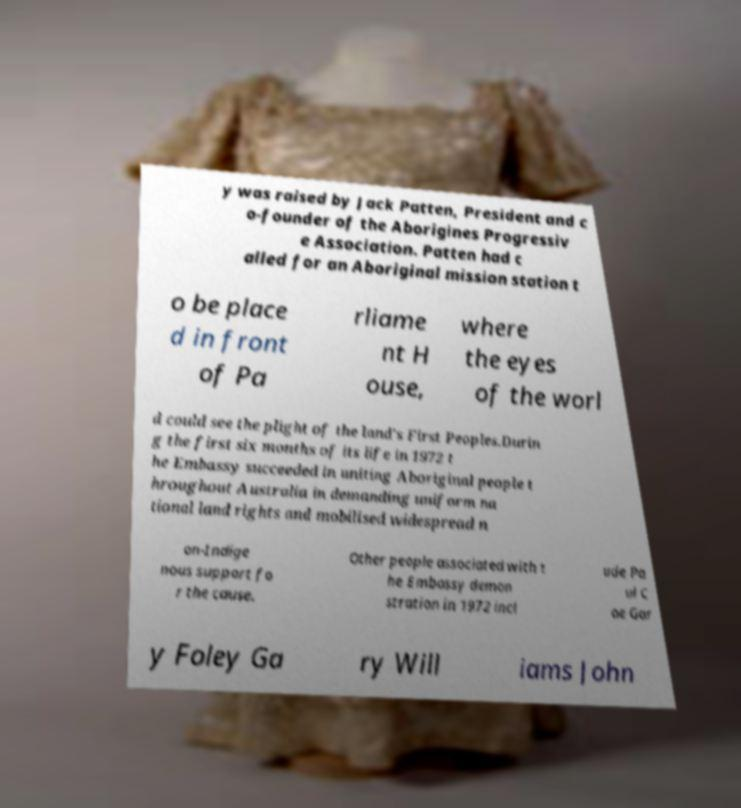I need the written content from this picture converted into text. Can you do that? y was raised by Jack Patten, President and c o-founder of the Aborigines Progressiv e Association. Patten had c alled for an Aboriginal mission station t o be place d in front of Pa rliame nt H ouse, where the eyes of the worl d could see the plight of the land's First Peoples.Durin g the first six months of its life in 1972 t he Embassy succeeded in uniting Aboriginal people t hroughout Australia in demanding uniform na tional land rights and mobilised widespread n on-Indige nous support fo r the cause. Other people associated with t he Embassy demon stration in 1972 incl ude Pa ul C oe Gar y Foley Ga ry Will iams John 